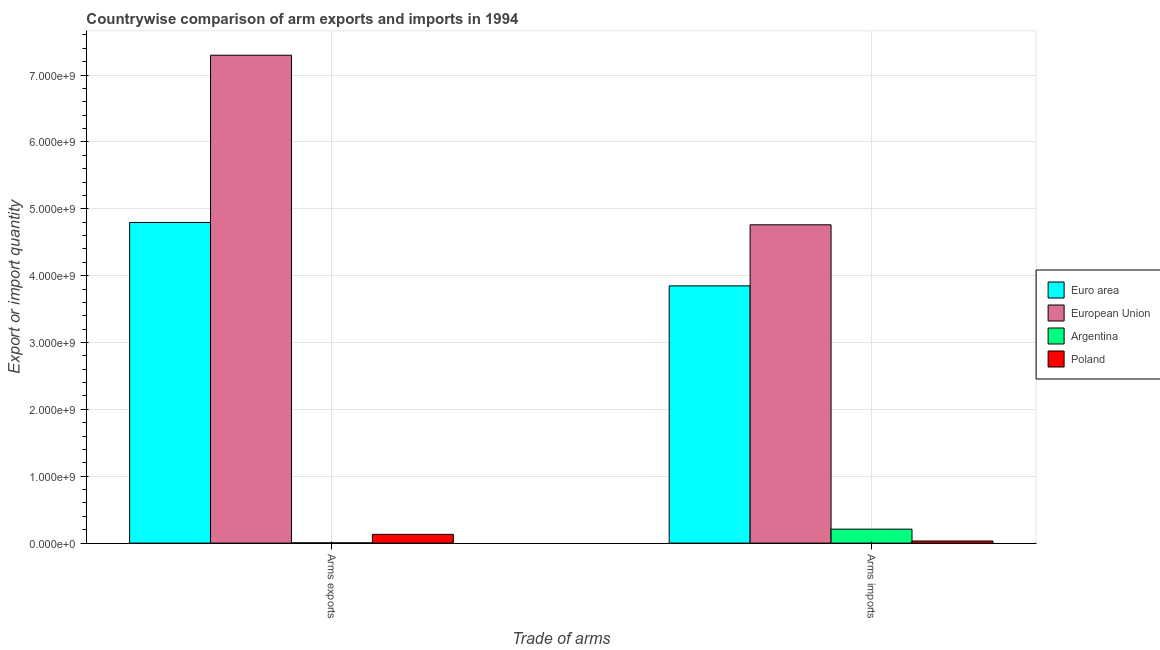What is the label of the 1st group of bars from the left?
Your response must be concise. Arms exports. What is the arms exports in Argentina?
Your answer should be very brief. 4.00e+06. Across all countries, what is the maximum arms imports?
Make the answer very short. 4.76e+09. Across all countries, what is the minimum arms imports?
Your response must be concise. 3.20e+07. In which country was the arms exports maximum?
Make the answer very short. European Union. What is the total arms imports in the graph?
Keep it short and to the point. 8.85e+09. What is the difference between the arms imports in European Union and that in Euro area?
Provide a succinct answer. 9.13e+08. What is the difference between the arms imports in Euro area and the arms exports in Argentina?
Ensure brevity in your answer.  3.84e+09. What is the average arms exports per country?
Provide a succinct answer. 3.06e+09. What is the difference between the arms imports and arms exports in Euro area?
Your answer should be very brief. -9.48e+08. In how many countries, is the arms exports greater than 6000000000 ?
Offer a very short reply. 1. What is the ratio of the arms imports in European Union to that in Poland?
Ensure brevity in your answer.  148.75. In how many countries, is the arms imports greater than the average arms imports taken over all countries?
Give a very brief answer. 2. What does the 1st bar from the left in Arms exports represents?
Make the answer very short. Euro area. What does the 4th bar from the right in Arms imports represents?
Offer a very short reply. Euro area. How many bars are there?
Provide a succinct answer. 8. How many countries are there in the graph?
Offer a very short reply. 4. What is the difference between two consecutive major ticks on the Y-axis?
Provide a short and direct response. 1.00e+09. Are the values on the major ticks of Y-axis written in scientific E-notation?
Your answer should be very brief. Yes. Where does the legend appear in the graph?
Your answer should be very brief. Center right. How many legend labels are there?
Your answer should be very brief. 4. What is the title of the graph?
Ensure brevity in your answer.  Countrywise comparison of arm exports and imports in 1994. Does "Turks and Caicos Islands" appear as one of the legend labels in the graph?
Offer a terse response. No. What is the label or title of the X-axis?
Offer a terse response. Trade of arms. What is the label or title of the Y-axis?
Provide a succinct answer. Export or import quantity. What is the Export or import quantity of Euro area in Arms exports?
Offer a terse response. 4.80e+09. What is the Export or import quantity of European Union in Arms exports?
Your response must be concise. 7.30e+09. What is the Export or import quantity of Poland in Arms exports?
Your answer should be very brief. 1.31e+08. What is the Export or import quantity in Euro area in Arms imports?
Offer a terse response. 3.85e+09. What is the Export or import quantity in European Union in Arms imports?
Provide a short and direct response. 4.76e+09. What is the Export or import quantity of Argentina in Arms imports?
Provide a succinct answer. 2.09e+08. What is the Export or import quantity of Poland in Arms imports?
Provide a short and direct response. 3.20e+07. Across all Trade of arms, what is the maximum Export or import quantity in Euro area?
Ensure brevity in your answer.  4.80e+09. Across all Trade of arms, what is the maximum Export or import quantity in European Union?
Offer a terse response. 7.30e+09. Across all Trade of arms, what is the maximum Export or import quantity in Argentina?
Make the answer very short. 2.09e+08. Across all Trade of arms, what is the maximum Export or import quantity of Poland?
Your answer should be very brief. 1.31e+08. Across all Trade of arms, what is the minimum Export or import quantity in Euro area?
Your answer should be very brief. 3.85e+09. Across all Trade of arms, what is the minimum Export or import quantity in European Union?
Your answer should be very brief. 4.76e+09. Across all Trade of arms, what is the minimum Export or import quantity in Argentina?
Your answer should be compact. 4.00e+06. Across all Trade of arms, what is the minimum Export or import quantity of Poland?
Give a very brief answer. 3.20e+07. What is the total Export or import quantity of Euro area in the graph?
Your answer should be very brief. 8.64e+09. What is the total Export or import quantity of European Union in the graph?
Provide a succinct answer. 1.21e+1. What is the total Export or import quantity of Argentina in the graph?
Give a very brief answer. 2.13e+08. What is the total Export or import quantity in Poland in the graph?
Offer a terse response. 1.63e+08. What is the difference between the Export or import quantity in Euro area in Arms exports and that in Arms imports?
Offer a terse response. 9.48e+08. What is the difference between the Export or import quantity of European Union in Arms exports and that in Arms imports?
Make the answer very short. 2.54e+09. What is the difference between the Export or import quantity of Argentina in Arms exports and that in Arms imports?
Provide a succinct answer. -2.05e+08. What is the difference between the Export or import quantity of Poland in Arms exports and that in Arms imports?
Offer a very short reply. 9.90e+07. What is the difference between the Export or import quantity of Euro area in Arms exports and the Export or import quantity of European Union in Arms imports?
Offer a very short reply. 3.50e+07. What is the difference between the Export or import quantity in Euro area in Arms exports and the Export or import quantity in Argentina in Arms imports?
Give a very brief answer. 4.59e+09. What is the difference between the Export or import quantity of Euro area in Arms exports and the Export or import quantity of Poland in Arms imports?
Offer a terse response. 4.76e+09. What is the difference between the Export or import quantity in European Union in Arms exports and the Export or import quantity in Argentina in Arms imports?
Offer a very short reply. 7.09e+09. What is the difference between the Export or import quantity in European Union in Arms exports and the Export or import quantity in Poland in Arms imports?
Provide a short and direct response. 7.26e+09. What is the difference between the Export or import quantity in Argentina in Arms exports and the Export or import quantity in Poland in Arms imports?
Your response must be concise. -2.80e+07. What is the average Export or import quantity in Euro area per Trade of arms?
Your answer should be very brief. 4.32e+09. What is the average Export or import quantity in European Union per Trade of arms?
Keep it short and to the point. 6.03e+09. What is the average Export or import quantity of Argentina per Trade of arms?
Provide a short and direct response. 1.06e+08. What is the average Export or import quantity in Poland per Trade of arms?
Your response must be concise. 8.15e+07. What is the difference between the Export or import quantity in Euro area and Export or import quantity in European Union in Arms exports?
Keep it short and to the point. -2.50e+09. What is the difference between the Export or import quantity in Euro area and Export or import quantity in Argentina in Arms exports?
Keep it short and to the point. 4.79e+09. What is the difference between the Export or import quantity of Euro area and Export or import quantity of Poland in Arms exports?
Provide a short and direct response. 4.66e+09. What is the difference between the Export or import quantity in European Union and Export or import quantity in Argentina in Arms exports?
Offer a terse response. 7.29e+09. What is the difference between the Export or import quantity in European Union and Export or import quantity in Poland in Arms exports?
Your response must be concise. 7.16e+09. What is the difference between the Export or import quantity of Argentina and Export or import quantity of Poland in Arms exports?
Keep it short and to the point. -1.27e+08. What is the difference between the Export or import quantity in Euro area and Export or import quantity in European Union in Arms imports?
Keep it short and to the point. -9.13e+08. What is the difference between the Export or import quantity in Euro area and Export or import quantity in Argentina in Arms imports?
Your response must be concise. 3.64e+09. What is the difference between the Export or import quantity of Euro area and Export or import quantity of Poland in Arms imports?
Ensure brevity in your answer.  3.82e+09. What is the difference between the Export or import quantity of European Union and Export or import quantity of Argentina in Arms imports?
Your response must be concise. 4.55e+09. What is the difference between the Export or import quantity in European Union and Export or import quantity in Poland in Arms imports?
Make the answer very short. 4.73e+09. What is the difference between the Export or import quantity in Argentina and Export or import quantity in Poland in Arms imports?
Your answer should be compact. 1.77e+08. What is the ratio of the Export or import quantity in Euro area in Arms exports to that in Arms imports?
Offer a very short reply. 1.25. What is the ratio of the Export or import quantity in European Union in Arms exports to that in Arms imports?
Ensure brevity in your answer.  1.53. What is the ratio of the Export or import quantity of Argentina in Arms exports to that in Arms imports?
Offer a terse response. 0.02. What is the ratio of the Export or import quantity in Poland in Arms exports to that in Arms imports?
Provide a short and direct response. 4.09. What is the difference between the highest and the second highest Export or import quantity in Euro area?
Your answer should be compact. 9.48e+08. What is the difference between the highest and the second highest Export or import quantity in European Union?
Offer a terse response. 2.54e+09. What is the difference between the highest and the second highest Export or import quantity of Argentina?
Provide a succinct answer. 2.05e+08. What is the difference between the highest and the second highest Export or import quantity in Poland?
Give a very brief answer. 9.90e+07. What is the difference between the highest and the lowest Export or import quantity of Euro area?
Provide a succinct answer. 9.48e+08. What is the difference between the highest and the lowest Export or import quantity of European Union?
Your answer should be compact. 2.54e+09. What is the difference between the highest and the lowest Export or import quantity of Argentina?
Provide a succinct answer. 2.05e+08. What is the difference between the highest and the lowest Export or import quantity of Poland?
Your answer should be compact. 9.90e+07. 